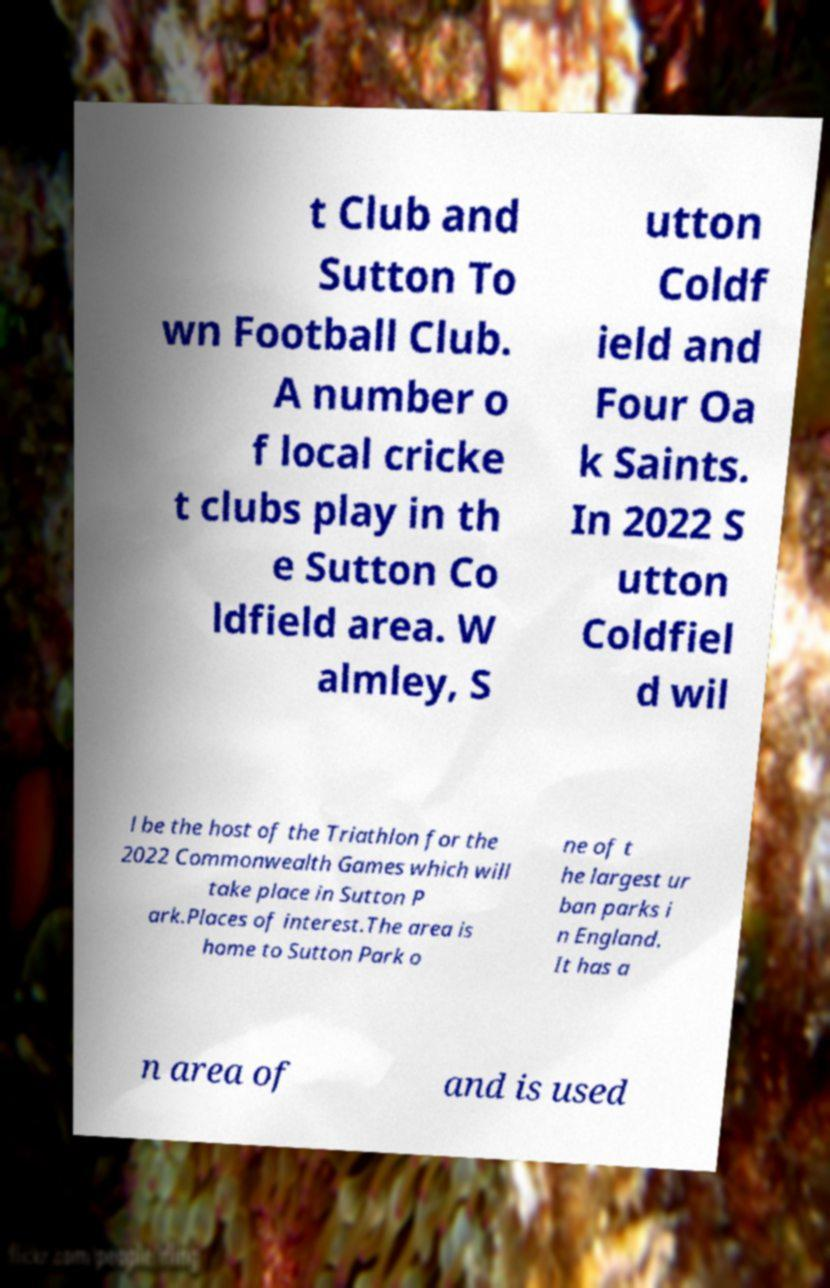Could you extract and type out the text from this image? t Club and Sutton To wn Football Club. A number o f local cricke t clubs play in th e Sutton Co ldfield area. W almley, S utton Coldf ield and Four Oa k Saints. In 2022 S utton Coldfiel d wil l be the host of the Triathlon for the 2022 Commonwealth Games which will take place in Sutton P ark.Places of interest.The area is home to Sutton Park o ne of t he largest ur ban parks i n England. It has a n area of and is used 